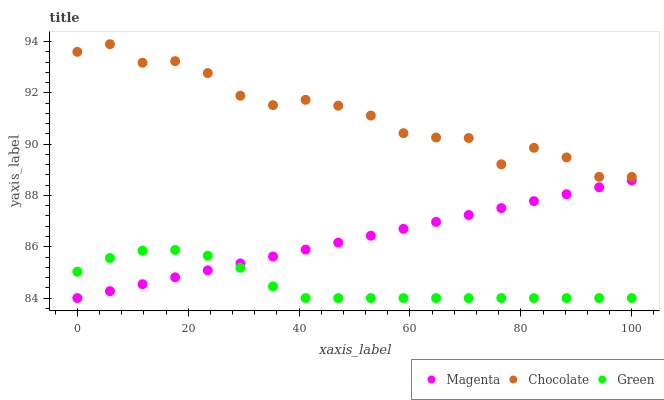Does Green have the minimum area under the curve?
Answer yes or no. Yes. Does Chocolate have the maximum area under the curve?
Answer yes or no. Yes. Does Chocolate have the minimum area under the curve?
Answer yes or no. No. Does Green have the maximum area under the curve?
Answer yes or no. No. Is Magenta the smoothest?
Answer yes or no. Yes. Is Chocolate the roughest?
Answer yes or no. Yes. Is Green the smoothest?
Answer yes or no. No. Is Green the roughest?
Answer yes or no. No. Does Magenta have the lowest value?
Answer yes or no. Yes. Does Chocolate have the lowest value?
Answer yes or no. No. Does Chocolate have the highest value?
Answer yes or no. Yes. Does Green have the highest value?
Answer yes or no. No. Is Magenta less than Chocolate?
Answer yes or no. Yes. Is Chocolate greater than Magenta?
Answer yes or no. Yes. Does Magenta intersect Green?
Answer yes or no. Yes. Is Magenta less than Green?
Answer yes or no. No. Is Magenta greater than Green?
Answer yes or no. No. Does Magenta intersect Chocolate?
Answer yes or no. No. 